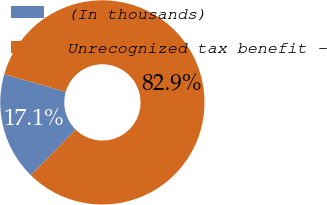<chart> <loc_0><loc_0><loc_500><loc_500><pie_chart><fcel>(In thousands)<fcel>Unrecognized tax benefit -<nl><fcel>17.11%<fcel>82.89%<nl></chart> 